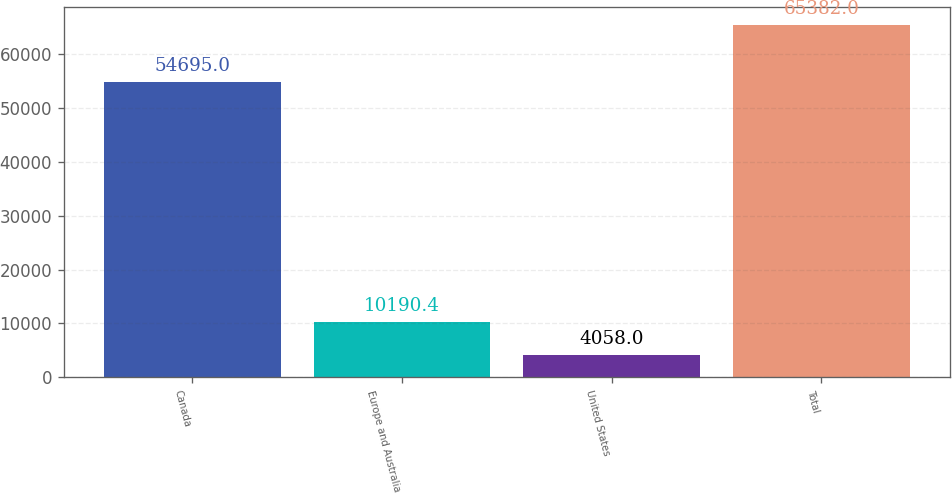Convert chart to OTSL. <chart><loc_0><loc_0><loc_500><loc_500><bar_chart><fcel>Canada<fcel>Europe and Australia<fcel>United States<fcel>Total<nl><fcel>54695<fcel>10190.4<fcel>4058<fcel>65382<nl></chart> 